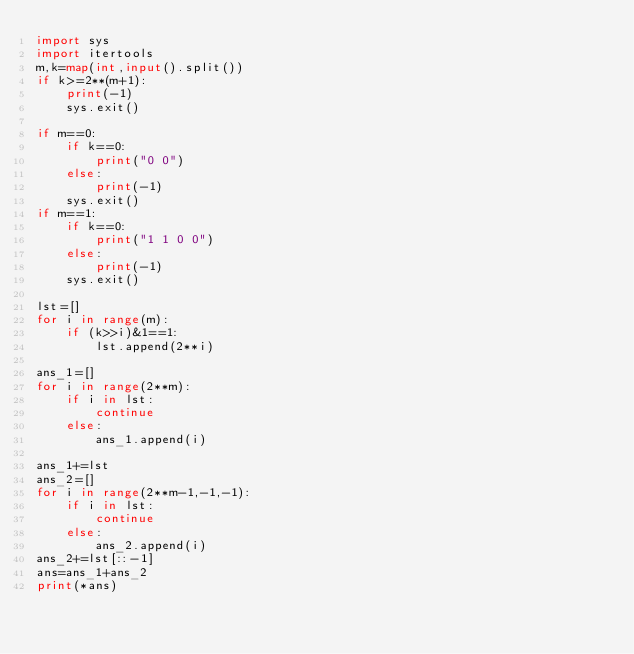<code> <loc_0><loc_0><loc_500><loc_500><_Python_>import sys
import itertools
m,k=map(int,input().split())
if k>=2**(m+1):
    print(-1)
    sys.exit()

if m==0:
    if k==0:
        print("0 0")
    else:
        print(-1)
    sys.exit()
if m==1:
    if k==0:
        print("1 1 0 0")
    else:
        print(-1)
    sys.exit()
    
lst=[]
for i in range(m):
    if (k>>i)&1==1:
        lst.append(2**i)
    
ans_1=[]
for i in range(2**m):
    if i in lst:
        continue
    else:
        ans_1.append(i)

ans_1+=lst
ans_2=[]
for i in range(2**m-1,-1,-1):
    if i in lst:
        continue
    else:
        ans_2.append(i)
ans_2+=lst[::-1]
ans=ans_1+ans_2
print(*ans)</code> 